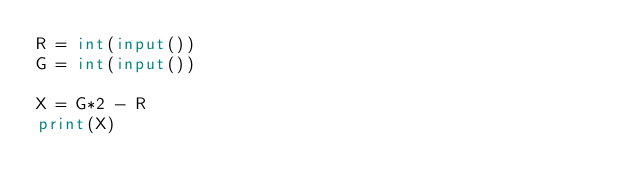Convert code to text. <code><loc_0><loc_0><loc_500><loc_500><_Python_>R = int(input())
G = int(input())

X = G*2 - R
print(X)</code> 